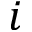<formula> <loc_0><loc_0><loc_500><loc_500>i</formula> 